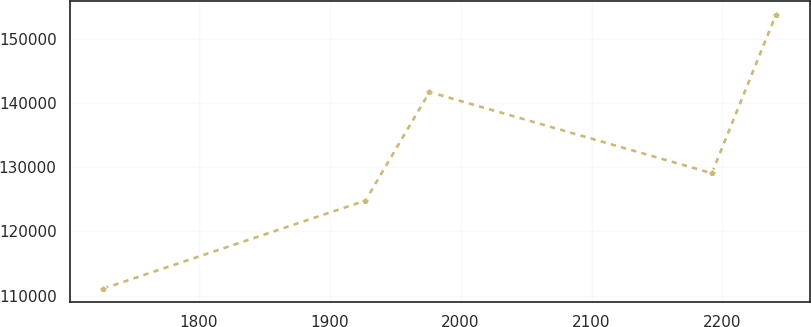Convert chart to OTSL. <chart><loc_0><loc_0><loc_500><loc_500><line_chart><ecel><fcel>Unnamed: 1<nl><fcel>1727.16<fcel>111090<nl><fcel>1927.3<fcel>124816<nl><fcel>1976.23<fcel>141748<nl><fcel>2191.92<fcel>129087<nl><fcel>2240.85<fcel>153801<nl></chart> 